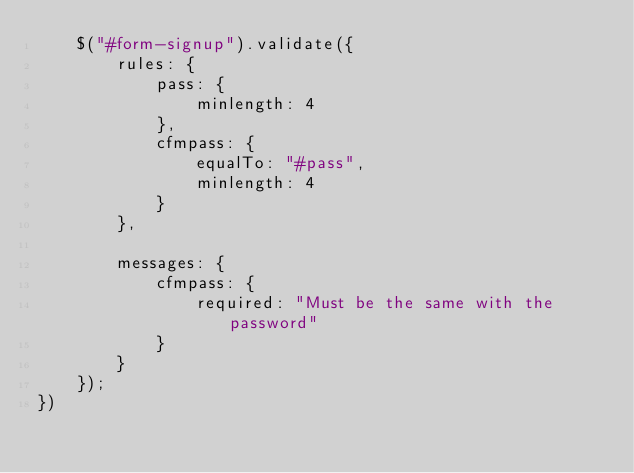<code> <loc_0><loc_0><loc_500><loc_500><_JavaScript_>	$("#form-signup").validate({
		rules: {
			pass: {
				minlength: 4
			},
			cfmpass: {
				equalTo: "#pass",
				minlength: 4
			}
		},
		
		messages: {
			cfmpass: {
				required: "Must be the same with the password"
			}
		}
	});
})</code> 